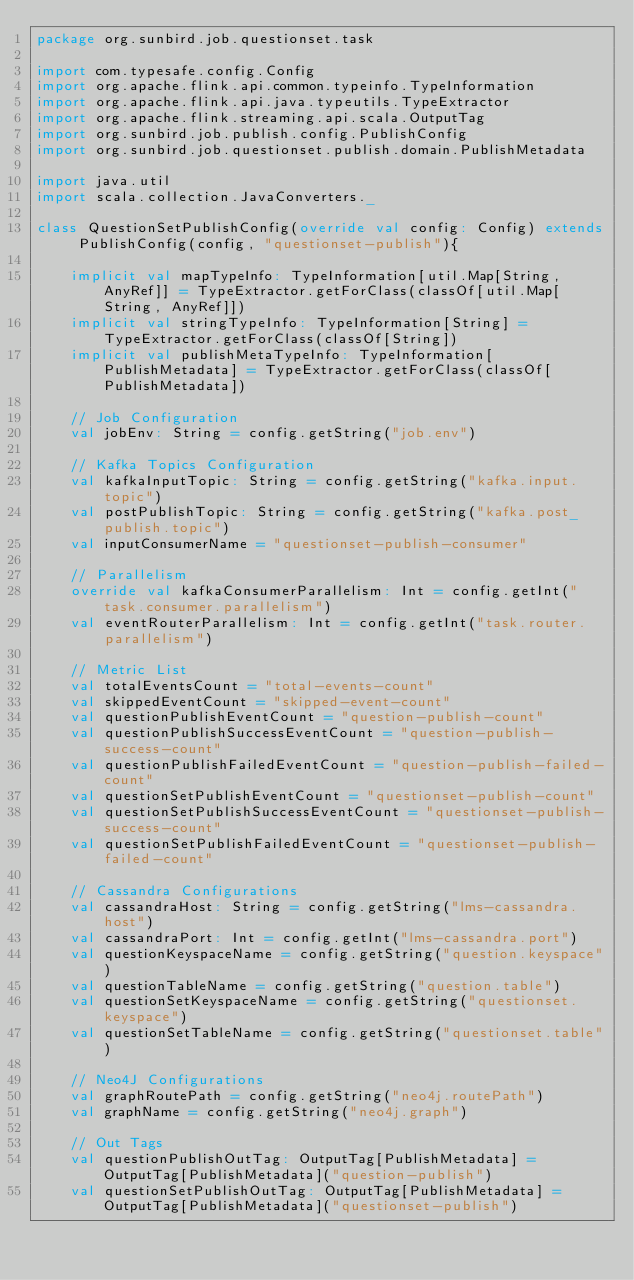Convert code to text. <code><loc_0><loc_0><loc_500><loc_500><_Scala_>package org.sunbird.job.questionset.task

import com.typesafe.config.Config
import org.apache.flink.api.common.typeinfo.TypeInformation
import org.apache.flink.api.java.typeutils.TypeExtractor
import org.apache.flink.streaming.api.scala.OutputTag
import org.sunbird.job.publish.config.PublishConfig
import org.sunbird.job.questionset.publish.domain.PublishMetadata

import java.util
import scala.collection.JavaConverters._

class QuestionSetPublishConfig(override val config: Config) extends PublishConfig(config, "questionset-publish"){

	implicit val mapTypeInfo: TypeInformation[util.Map[String, AnyRef]] = TypeExtractor.getForClass(classOf[util.Map[String, AnyRef]])
	implicit val stringTypeInfo: TypeInformation[String] = TypeExtractor.getForClass(classOf[String])
	implicit val publishMetaTypeInfo: TypeInformation[PublishMetadata] = TypeExtractor.getForClass(classOf[PublishMetadata])

	// Job Configuration
	val jobEnv: String = config.getString("job.env")

	// Kafka Topics Configuration
	val kafkaInputTopic: String = config.getString("kafka.input.topic")
	val postPublishTopic: String = config.getString("kafka.post_publish.topic")
	val inputConsumerName = "questionset-publish-consumer"

	// Parallelism
	override val kafkaConsumerParallelism: Int = config.getInt("task.consumer.parallelism")
	val eventRouterParallelism: Int = config.getInt("task.router.parallelism")

	// Metric List
	val totalEventsCount = "total-events-count"
	val skippedEventCount = "skipped-event-count"
	val questionPublishEventCount = "question-publish-count"
	val questionPublishSuccessEventCount = "question-publish-success-count"
	val questionPublishFailedEventCount = "question-publish-failed-count"
	val questionSetPublishEventCount = "questionset-publish-count"
	val questionSetPublishSuccessEventCount = "questionset-publish-success-count"
	val questionSetPublishFailedEventCount = "questionset-publish-failed-count"

	// Cassandra Configurations
	val cassandraHost: String = config.getString("lms-cassandra.host")
	val cassandraPort: Int = config.getInt("lms-cassandra.port")
	val questionKeyspaceName = config.getString("question.keyspace")
	val questionTableName = config.getString("question.table")
	val questionSetKeyspaceName = config.getString("questionset.keyspace")
	val questionSetTableName = config.getString("questionset.table")

	// Neo4J Configurations
	val graphRoutePath = config.getString("neo4j.routePath")
	val graphName = config.getString("neo4j.graph")

	// Out Tags
	val questionPublishOutTag: OutputTag[PublishMetadata] = OutputTag[PublishMetadata]("question-publish")
	val questionSetPublishOutTag: OutputTag[PublishMetadata] = OutputTag[PublishMetadata]("questionset-publish")
</code> 